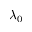<formula> <loc_0><loc_0><loc_500><loc_500>\lambda _ { 0 }</formula> 